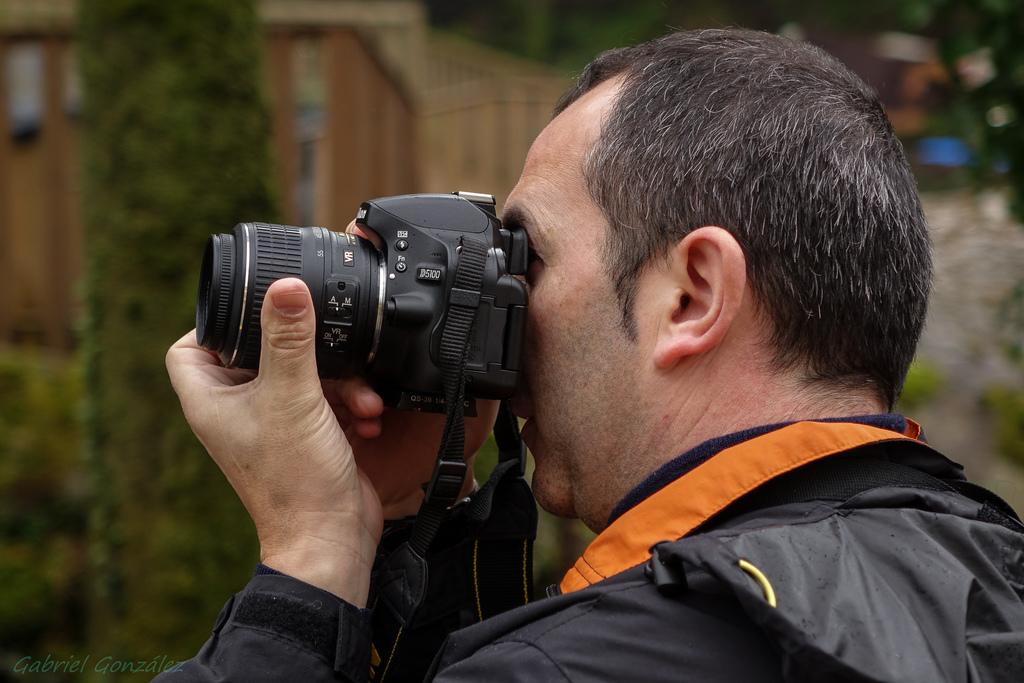What is the man in the image doing? The man is holding a camera and clicking a picture. What is the man wearing in the image? The man is wearing a black jacket. What can be seen in the background of the image? There is a building and trees in the background of the image. What type of birds can be seen flying around the man in the image? There are no birds visible in the image. What is the man using to tighten the screws on the camera in the image? There is no screw or any indication of the man tightening screws in the image; he is simply holding and clicking a picture. 